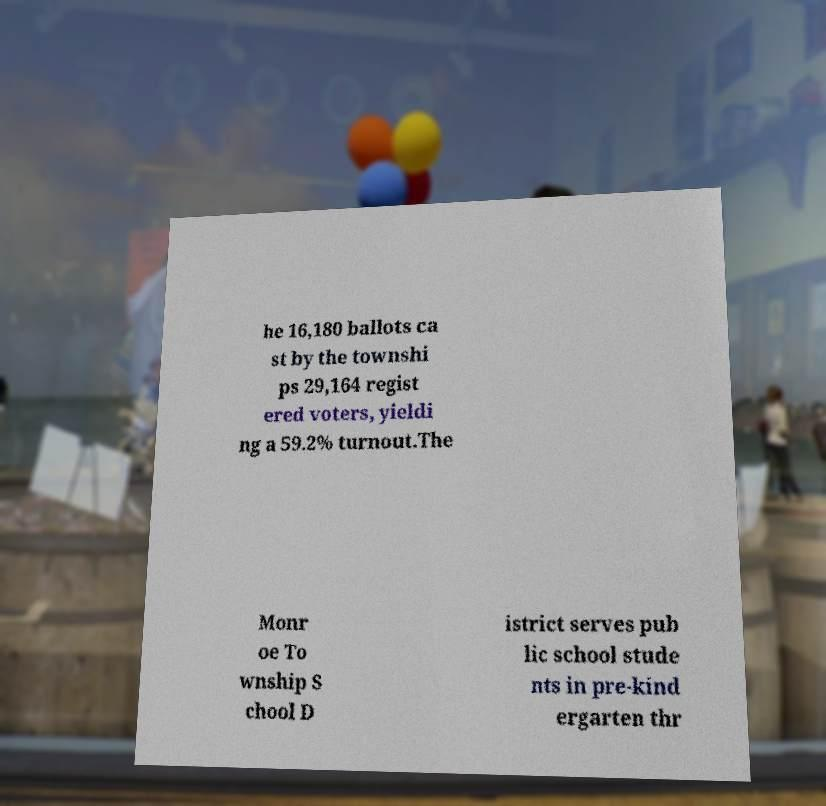Could you assist in decoding the text presented in this image and type it out clearly? he 16,180 ballots ca st by the townshi ps 29,164 regist ered voters, yieldi ng a 59.2% turnout.The Monr oe To wnship S chool D istrict serves pub lic school stude nts in pre-kind ergarten thr 